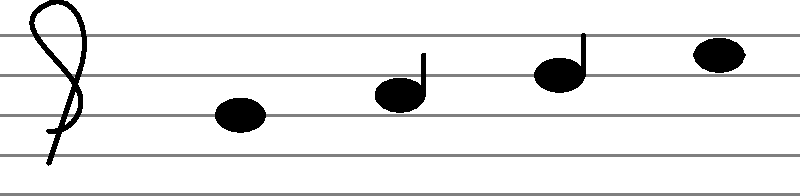As a jazz musician who incorporates vinyl sampled beats, you need to accurately identify note durations. Looking at the musical staff above, what is the duration of the last note (furthest to the right) in relation to the first note? To determine the relative duration of the notes, we need to analyze their visual representation:

1. The first note (leftmost) is a filled oval without a stem. This represents a whole note, which has the longest duration among basic note values.

2. The second note has a filled oval with a stem. This is a quarter note, which has 1/4 the duration of a whole note.

3. The third note is similar to the second but with an additional flag on the stem. This is an eighth note, with 1/8 the duration of a whole note.

4. The last note (rightmost) has a filled oval, a stem, and a horizontal line through the stem. This represents a half note, which has 1/2 the duration of a whole note.

To compare the last note to the first note:
- The first note is a whole note (1 whole)
- The last note is a half note (1/2 whole)

Therefore, the duration of the last note is half that of the first note.
Answer: 1/2 or half 